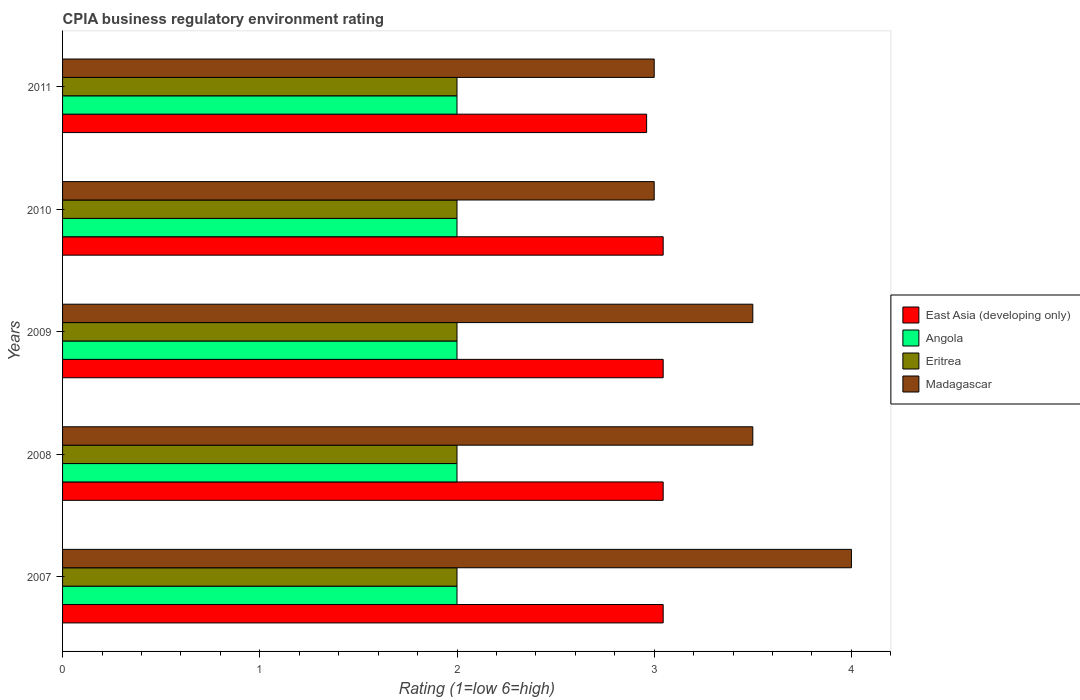How many groups of bars are there?
Keep it short and to the point. 5. How many bars are there on the 5th tick from the top?
Make the answer very short. 4. What is the label of the 5th group of bars from the top?
Offer a very short reply. 2007. In how many cases, is the number of bars for a given year not equal to the number of legend labels?
Your answer should be very brief. 0. What is the CPIA rating in Madagascar in 2007?
Provide a short and direct response. 4. Across all years, what is the maximum CPIA rating in East Asia (developing only)?
Make the answer very short. 3.05. What is the total CPIA rating in Angola in the graph?
Offer a terse response. 10. What is the difference between the CPIA rating in East Asia (developing only) in 2009 and that in 2010?
Offer a terse response. 0. What is the difference between the CPIA rating in Angola in 2009 and the CPIA rating in Madagascar in 2008?
Provide a succinct answer. -1.5. In the year 2008, what is the difference between the CPIA rating in East Asia (developing only) and CPIA rating in Madagascar?
Offer a very short reply. -0.45. What is the difference between the highest and the second highest CPIA rating in East Asia (developing only)?
Keep it short and to the point. 0. What is the difference between the highest and the lowest CPIA rating in Eritrea?
Your response must be concise. 0. In how many years, is the CPIA rating in East Asia (developing only) greater than the average CPIA rating in East Asia (developing only) taken over all years?
Provide a succinct answer. 4. Is it the case that in every year, the sum of the CPIA rating in East Asia (developing only) and CPIA rating in Eritrea is greater than the sum of CPIA rating in Angola and CPIA rating in Madagascar?
Offer a terse response. No. What does the 3rd bar from the top in 2010 represents?
Give a very brief answer. Angola. What does the 1st bar from the bottom in 2007 represents?
Keep it short and to the point. East Asia (developing only). Is it the case that in every year, the sum of the CPIA rating in East Asia (developing only) and CPIA rating in Angola is greater than the CPIA rating in Madagascar?
Your answer should be compact. Yes. How many bars are there?
Provide a short and direct response. 20. What is the difference between two consecutive major ticks on the X-axis?
Keep it short and to the point. 1. Are the values on the major ticks of X-axis written in scientific E-notation?
Offer a terse response. No. How are the legend labels stacked?
Your answer should be very brief. Vertical. What is the title of the graph?
Give a very brief answer. CPIA business regulatory environment rating. What is the label or title of the Y-axis?
Your answer should be compact. Years. What is the Rating (1=low 6=high) of East Asia (developing only) in 2007?
Ensure brevity in your answer.  3.05. What is the Rating (1=low 6=high) in Eritrea in 2007?
Keep it short and to the point. 2. What is the Rating (1=low 6=high) in Madagascar in 2007?
Your answer should be compact. 4. What is the Rating (1=low 6=high) in East Asia (developing only) in 2008?
Provide a succinct answer. 3.05. What is the Rating (1=low 6=high) in Angola in 2008?
Your response must be concise. 2. What is the Rating (1=low 6=high) of Eritrea in 2008?
Your response must be concise. 2. What is the Rating (1=low 6=high) of East Asia (developing only) in 2009?
Your response must be concise. 3.05. What is the Rating (1=low 6=high) in East Asia (developing only) in 2010?
Keep it short and to the point. 3.05. What is the Rating (1=low 6=high) of Eritrea in 2010?
Your answer should be compact. 2. What is the Rating (1=low 6=high) in Madagascar in 2010?
Keep it short and to the point. 3. What is the Rating (1=low 6=high) of East Asia (developing only) in 2011?
Your answer should be very brief. 2.96. What is the Rating (1=low 6=high) of Angola in 2011?
Keep it short and to the point. 2. What is the Rating (1=low 6=high) in Eritrea in 2011?
Provide a short and direct response. 2. Across all years, what is the maximum Rating (1=low 6=high) in East Asia (developing only)?
Your answer should be compact. 3.05. Across all years, what is the minimum Rating (1=low 6=high) of East Asia (developing only)?
Your answer should be very brief. 2.96. Across all years, what is the minimum Rating (1=low 6=high) in Angola?
Provide a succinct answer. 2. Across all years, what is the minimum Rating (1=low 6=high) in Madagascar?
Make the answer very short. 3. What is the total Rating (1=low 6=high) in East Asia (developing only) in the graph?
Make the answer very short. 15.14. What is the total Rating (1=low 6=high) of Eritrea in the graph?
Give a very brief answer. 10. What is the difference between the Rating (1=low 6=high) of Eritrea in 2007 and that in 2008?
Your response must be concise. 0. What is the difference between the Rating (1=low 6=high) in Madagascar in 2007 and that in 2008?
Your answer should be very brief. 0.5. What is the difference between the Rating (1=low 6=high) of East Asia (developing only) in 2007 and that in 2009?
Offer a very short reply. 0. What is the difference between the Rating (1=low 6=high) of Angola in 2007 and that in 2009?
Keep it short and to the point. 0. What is the difference between the Rating (1=low 6=high) in Madagascar in 2007 and that in 2009?
Ensure brevity in your answer.  0.5. What is the difference between the Rating (1=low 6=high) of East Asia (developing only) in 2007 and that in 2010?
Offer a terse response. 0. What is the difference between the Rating (1=low 6=high) of East Asia (developing only) in 2007 and that in 2011?
Make the answer very short. 0.08. What is the difference between the Rating (1=low 6=high) of Eritrea in 2007 and that in 2011?
Offer a terse response. 0. What is the difference between the Rating (1=low 6=high) in Angola in 2008 and that in 2009?
Your answer should be very brief. 0. What is the difference between the Rating (1=low 6=high) in Eritrea in 2008 and that in 2009?
Your response must be concise. 0. What is the difference between the Rating (1=low 6=high) in Madagascar in 2008 and that in 2009?
Ensure brevity in your answer.  0. What is the difference between the Rating (1=low 6=high) of Angola in 2008 and that in 2010?
Your answer should be compact. 0. What is the difference between the Rating (1=low 6=high) in East Asia (developing only) in 2008 and that in 2011?
Ensure brevity in your answer.  0.08. What is the difference between the Rating (1=low 6=high) of Eritrea in 2008 and that in 2011?
Your response must be concise. 0. What is the difference between the Rating (1=low 6=high) in Madagascar in 2008 and that in 2011?
Your response must be concise. 0.5. What is the difference between the Rating (1=low 6=high) of Angola in 2009 and that in 2010?
Your answer should be compact. 0. What is the difference between the Rating (1=low 6=high) in Madagascar in 2009 and that in 2010?
Give a very brief answer. 0.5. What is the difference between the Rating (1=low 6=high) of East Asia (developing only) in 2009 and that in 2011?
Offer a very short reply. 0.08. What is the difference between the Rating (1=low 6=high) in Angola in 2009 and that in 2011?
Your answer should be very brief. 0. What is the difference between the Rating (1=low 6=high) of East Asia (developing only) in 2010 and that in 2011?
Offer a very short reply. 0.08. What is the difference between the Rating (1=low 6=high) of Angola in 2010 and that in 2011?
Offer a very short reply. 0. What is the difference between the Rating (1=low 6=high) in Madagascar in 2010 and that in 2011?
Ensure brevity in your answer.  0. What is the difference between the Rating (1=low 6=high) in East Asia (developing only) in 2007 and the Rating (1=low 6=high) in Angola in 2008?
Provide a short and direct response. 1.05. What is the difference between the Rating (1=low 6=high) in East Asia (developing only) in 2007 and the Rating (1=low 6=high) in Eritrea in 2008?
Keep it short and to the point. 1.05. What is the difference between the Rating (1=low 6=high) of East Asia (developing only) in 2007 and the Rating (1=low 6=high) of Madagascar in 2008?
Ensure brevity in your answer.  -0.45. What is the difference between the Rating (1=low 6=high) in Angola in 2007 and the Rating (1=low 6=high) in Eritrea in 2008?
Make the answer very short. 0. What is the difference between the Rating (1=low 6=high) of East Asia (developing only) in 2007 and the Rating (1=low 6=high) of Angola in 2009?
Make the answer very short. 1.05. What is the difference between the Rating (1=low 6=high) in East Asia (developing only) in 2007 and the Rating (1=low 6=high) in Eritrea in 2009?
Ensure brevity in your answer.  1.05. What is the difference between the Rating (1=low 6=high) in East Asia (developing only) in 2007 and the Rating (1=low 6=high) in Madagascar in 2009?
Your answer should be very brief. -0.45. What is the difference between the Rating (1=low 6=high) of Eritrea in 2007 and the Rating (1=low 6=high) of Madagascar in 2009?
Your answer should be compact. -1.5. What is the difference between the Rating (1=low 6=high) of East Asia (developing only) in 2007 and the Rating (1=low 6=high) of Angola in 2010?
Provide a short and direct response. 1.05. What is the difference between the Rating (1=low 6=high) of East Asia (developing only) in 2007 and the Rating (1=low 6=high) of Eritrea in 2010?
Your answer should be very brief. 1.05. What is the difference between the Rating (1=low 6=high) of East Asia (developing only) in 2007 and the Rating (1=low 6=high) of Madagascar in 2010?
Offer a terse response. 0.05. What is the difference between the Rating (1=low 6=high) in East Asia (developing only) in 2007 and the Rating (1=low 6=high) in Angola in 2011?
Give a very brief answer. 1.05. What is the difference between the Rating (1=low 6=high) in East Asia (developing only) in 2007 and the Rating (1=low 6=high) in Eritrea in 2011?
Make the answer very short. 1.05. What is the difference between the Rating (1=low 6=high) in East Asia (developing only) in 2007 and the Rating (1=low 6=high) in Madagascar in 2011?
Keep it short and to the point. 0.05. What is the difference between the Rating (1=low 6=high) in Angola in 2007 and the Rating (1=low 6=high) in Madagascar in 2011?
Keep it short and to the point. -1. What is the difference between the Rating (1=low 6=high) of East Asia (developing only) in 2008 and the Rating (1=low 6=high) of Angola in 2009?
Provide a succinct answer. 1.05. What is the difference between the Rating (1=low 6=high) of East Asia (developing only) in 2008 and the Rating (1=low 6=high) of Eritrea in 2009?
Keep it short and to the point. 1.05. What is the difference between the Rating (1=low 6=high) in East Asia (developing only) in 2008 and the Rating (1=low 6=high) in Madagascar in 2009?
Provide a succinct answer. -0.45. What is the difference between the Rating (1=low 6=high) in Angola in 2008 and the Rating (1=low 6=high) in Madagascar in 2009?
Provide a short and direct response. -1.5. What is the difference between the Rating (1=low 6=high) of Eritrea in 2008 and the Rating (1=low 6=high) of Madagascar in 2009?
Offer a terse response. -1.5. What is the difference between the Rating (1=low 6=high) in East Asia (developing only) in 2008 and the Rating (1=low 6=high) in Angola in 2010?
Your response must be concise. 1.05. What is the difference between the Rating (1=low 6=high) of East Asia (developing only) in 2008 and the Rating (1=low 6=high) of Eritrea in 2010?
Ensure brevity in your answer.  1.05. What is the difference between the Rating (1=low 6=high) in East Asia (developing only) in 2008 and the Rating (1=low 6=high) in Madagascar in 2010?
Your answer should be compact. 0.05. What is the difference between the Rating (1=low 6=high) in East Asia (developing only) in 2008 and the Rating (1=low 6=high) in Angola in 2011?
Ensure brevity in your answer.  1.05. What is the difference between the Rating (1=low 6=high) in East Asia (developing only) in 2008 and the Rating (1=low 6=high) in Eritrea in 2011?
Make the answer very short. 1.05. What is the difference between the Rating (1=low 6=high) of East Asia (developing only) in 2008 and the Rating (1=low 6=high) of Madagascar in 2011?
Give a very brief answer. 0.05. What is the difference between the Rating (1=low 6=high) in Angola in 2008 and the Rating (1=low 6=high) in Eritrea in 2011?
Offer a very short reply. 0. What is the difference between the Rating (1=low 6=high) in Eritrea in 2008 and the Rating (1=low 6=high) in Madagascar in 2011?
Your answer should be compact. -1. What is the difference between the Rating (1=low 6=high) in East Asia (developing only) in 2009 and the Rating (1=low 6=high) in Angola in 2010?
Your response must be concise. 1.05. What is the difference between the Rating (1=low 6=high) of East Asia (developing only) in 2009 and the Rating (1=low 6=high) of Eritrea in 2010?
Offer a very short reply. 1.05. What is the difference between the Rating (1=low 6=high) of East Asia (developing only) in 2009 and the Rating (1=low 6=high) of Madagascar in 2010?
Offer a terse response. 0.05. What is the difference between the Rating (1=low 6=high) of Angola in 2009 and the Rating (1=low 6=high) of Madagascar in 2010?
Your response must be concise. -1. What is the difference between the Rating (1=low 6=high) of East Asia (developing only) in 2009 and the Rating (1=low 6=high) of Angola in 2011?
Ensure brevity in your answer.  1.05. What is the difference between the Rating (1=low 6=high) of East Asia (developing only) in 2009 and the Rating (1=low 6=high) of Eritrea in 2011?
Keep it short and to the point. 1.05. What is the difference between the Rating (1=low 6=high) in East Asia (developing only) in 2009 and the Rating (1=low 6=high) in Madagascar in 2011?
Provide a succinct answer. 0.05. What is the difference between the Rating (1=low 6=high) of Eritrea in 2009 and the Rating (1=low 6=high) of Madagascar in 2011?
Keep it short and to the point. -1. What is the difference between the Rating (1=low 6=high) of East Asia (developing only) in 2010 and the Rating (1=low 6=high) of Angola in 2011?
Your response must be concise. 1.05. What is the difference between the Rating (1=low 6=high) in East Asia (developing only) in 2010 and the Rating (1=low 6=high) in Eritrea in 2011?
Ensure brevity in your answer.  1.05. What is the difference between the Rating (1=low 6=high) in East Asia (developing only) in 2010 and the Rating (1=low 6=high) in Madagascar in 2011?
Your answer should be very brief. 0.05. What is the difference between the Rating (1=low 6=high) of Angola in 2010 and the Rating (1=low 6=high) of Madagascar in 2011?
Your answer should be very brief. -1. What is the difference between the Rating (1=low 6=high) in Eritrea in 2010 and the Rating (1=low 6=high) in Madagascar in 2011?
Provide a succinct answer. -1. What is the average Rating (1=low 6=high) of East Asia (developing only) per year?
Your answer should be very brief. 3.03. What is the average Rating (1=low 6=high) in Angola per year?
Your answer should be very brief. 2. What is the average Rating (1=low 6=high) in Madagascar per year?
Make the answer very short. 3.4. In the year 2007, what is the difference between the Rating (1=low 6=high) of East Asia (developing only) and Rating (1=low 6=high) of Angola?
Offer a terse response. 1.05. In the year 2007, what is the difference between the Rating (1=low 6=high) in East Asia (developing only) and Rating (1=low 6=high) in Eritrea?
Your answer should be very brief. 1.05. In the year 2007, what is the difference between the Rating (1=low 6=high) in East Asia (developing only) and Rating (1=low 6=high) in Madagascar?
Provide a succinct answer. -0.95. In the year 2007, what is the difference between the Rating (1=low 6=high) in Angola and Rating (1=low 6=high) in Eritrea?
Your answer should be very brief. 0. In the year 2007, what is the difference between the Rating (1=low 6=high) of Eritrea and Rating (1=low 6=high) of Madagascar?
Provide a short and direct response. -2. In the year 2008, what is the difference between the Rating (1=low 6=high) in East Asia (developing only) and Rating (1=low 6=high) in Angola?
Give a very brief answer. 1.05. In the year 2008, what is the difference between the Rating (1=low 6=high) of East Asia (developing only) and Rating (1=low 6=high) of Eritrea?
Offer a terse response. 1.05. In the year 2008, what is the difference between the Rating (1=low 6=high) of East Asia (developing only) and Rating (1=low 6=high) of Madagascar?
Ensure brevity in your answer.  -0.45. In the year 2008, what is the difference between the Rating (1=low 6=high) in Angola and Rating (1=low 6=high) in Eritrea?
Make the answer very short. 0. In the year 2008, what is the difference between the Rating (1=low 6=high) of Angola and Rating (1=low 6=high) of Madagascar?
Ensure brevity in your answer.  -1.5. In the year 2008, what is the difference between the Rating (1=low 6=high) of Eritrea and Rating (1=low 6=high) of Madagascar?
Ensure brevity in your answer.  -1.5. In the year 2009, what is the difference between the Rating (1=low 6=high) in East Asia (developing only) and Rating (1=low 6=high) in Angola?
Keep it short and to the point. 1.05. In the year 2009, what is the difference between the Rating (1=low 6=high) of East Asia (developing only) and Rating (1=low 6=high) of Eritrea?
Give a very brief answer. 1.05. In the year 2009, what is the difference between the Rating (1=low 6=high) in East Asia (developing only) and Rating (1=low 6=high) in Madagascar?
Offer a very short reply. -0.45. In the year 2009, what is the difference between the Rating (1=low 6=high) in Angola and Rating (1=low 6=high) in Madagascar?
Provide a short and direct response. -1.5. In the year 2009, what is the difference between the Rating (1=low 6=high) in Eritrea and Rating (1=low 6=high) in Madagascar?
Provide a short and direct response. -1.5. In the year 2010, what is the difference between the Rating (1=low 6=high) of East Asia (developing only) and Rating (1=low 6=high) of Angola?
Provide a short and direct response. 1.05. In the year 2010, what is the difference between the Rating (1=low 6=high) in East Asia (developing only) and Rating (1=low 6=high) in Eritrea?
Your response must be concise. 1.05. In the year 2010, what is the difference between the Rating (1=low 6=high) in East Asia (developing only) and Rating (1=low 6=high) in Madagascar?
Ensure brevity in your answer.  0.05. In the year 2011, what is the difference between the Rating (1=low 6=high) of East Asia (developing only) and Rating (1=low 6=high) of Angola?
Your answer should be very brief. 0.96. In the year 2011, what is the difference between the Rating (1=low 6=high) in East Asia (developing only) and Rating (1=low 6=high) in Eritrea?
Your answer should be compact. 0.96. In the year 2011, what is the difference between the Rating (1=low 6=high) of East Asia (developing only) and Rating (1=low 6=high) of Madagascar?
Your response must be concise. -0.04. In the year 2011, what is the difference between the Rating (1=low 6=high) of Angola and Rating (1=low 6=high) of Eritrea?
Keep it short and to the point. 0. In the year 2011, what is the difference between the Rating (1=low 6=high) in Angola and Rating (1=low 6=high) in Madagascar?
Provide a succinct answer. -1. What is the ratio of the Rating (1=low 6=high) in East Asia (developing only) in 2007 to that in 2008?
Offer a terse response. 1. What is the ratio of the Rating (1=low 6=high) in Angola in 2007 to that in 2008?
Your answer should be very brief. 1. What is the ratio of the Rating (1=low 6=high) in Eritrea in 2007 to that in 2009?
Offer a terse response. 1. What is the ratio of the Rating (1=low 6=high) in Madagascar in 2007 to that in 2009?
Make the answer very short. 1.14. What is the ratio of the Rating (1=low 6=high) of Angola in 2007 to that in 2010?
Make the answer very short. 1. What is the ratio of the Rating (1=low 6=high) of Madagascar in 2007 to that in 2010?
Your response must be concise. 1.33. What is the ratio of the Rating (1=low 6=high) in East Asia (developing only) in 2007 to that in 2011?
Offer a very short reply. 1.03. What is the ratio of the Rating (1=low 6=high) of Madagascar in 2007 to that in 2011?
Keep it short and to the point. 1.33. What is the ratio of the Rating (1=low 6=high) in East Asia (developing only) in 2008 to that in 2009?
Provide a short and direct response. 1. What is the ratio of the Rating (1=low 6=high) in Madagascar in 2008 to that in 2009?
Your answer should be very brief. 1. What is the ratio of the Rating (1=low 6=high) of East Asia (developing only) in 2008 to that in 2010?
Your answer should be compact. 1. What is the ratio of the Rating (1=low 6=high) of Angola in 2008 to that in 2010?
Ensure brevity in your answer.  1. What is the ratio of the Rating (1=low 6=high) in Eritrea in 2008 to that in 2010?
Give a very brief answer. 1. What is the ratio of the Rating (1=low 6=high) in East Asia (developing only) in 2008 to that in 2011?
Your answer should be very brief. 1.03. What is the ratio of the Rating (1=low 6=high) in Angola in 2008 to that in 2011?
Ensure brevity in your answer.  1. What is the ratio of the Rating (1=low 6=high) of East Asia (developing only) in 2009 to that in 2010?
Keep it short and to the point. 1. What is the ratio of the Rating (1=low 6=high) of Angola in 2009 to that in 2010?
Give a very brief answer. 1. What is the ratio of the Rating (1=low 6=high) of Eritrea in 2009 to that in 2010?
Give a very brief answer. 1. What is the ratio of the Rating (1=low 6=high) of Madagascar in 2009 to that in 2010?
Give a very brief answer. 1.17. What is the ratio of the Rating (1=low 6=high) of East Asia (developing only) in 2009 to that in 2011?
Provide a succinct answer. 1.03. What is the ratio of the Rating (1=low 6=high) in Madagascar in 2009 to that in 2011?
Make the answer very short. 1.17. What is the ratio of the Rating (1=low 6=high) in East Asia (developing only) in 2010 to that in 2011?
Give a very brief answer. 1.03. What is the ratio of the Rating (1=low 6=high) of Angola in 2010 to that in 2011?
Your answer should be very brief. 1. What is the difference between the highest and the second highest Rating (1=low 6=high) in East Asia (developing only)?
Your response must be concise. 0. What is the difference between the highest and the second highest Rating (1=low 6=high) in Eritrea?
Make the answer very short. 0. What is the difference between the highest and the lowest Rating (1=low 6=high) of East Asia (developing only)?
Your answer should be compact. 0.08. What is the difference between the highest and the lowest Rating (1=low 6=high) of Angola?
Offer a very short reply. 0. 